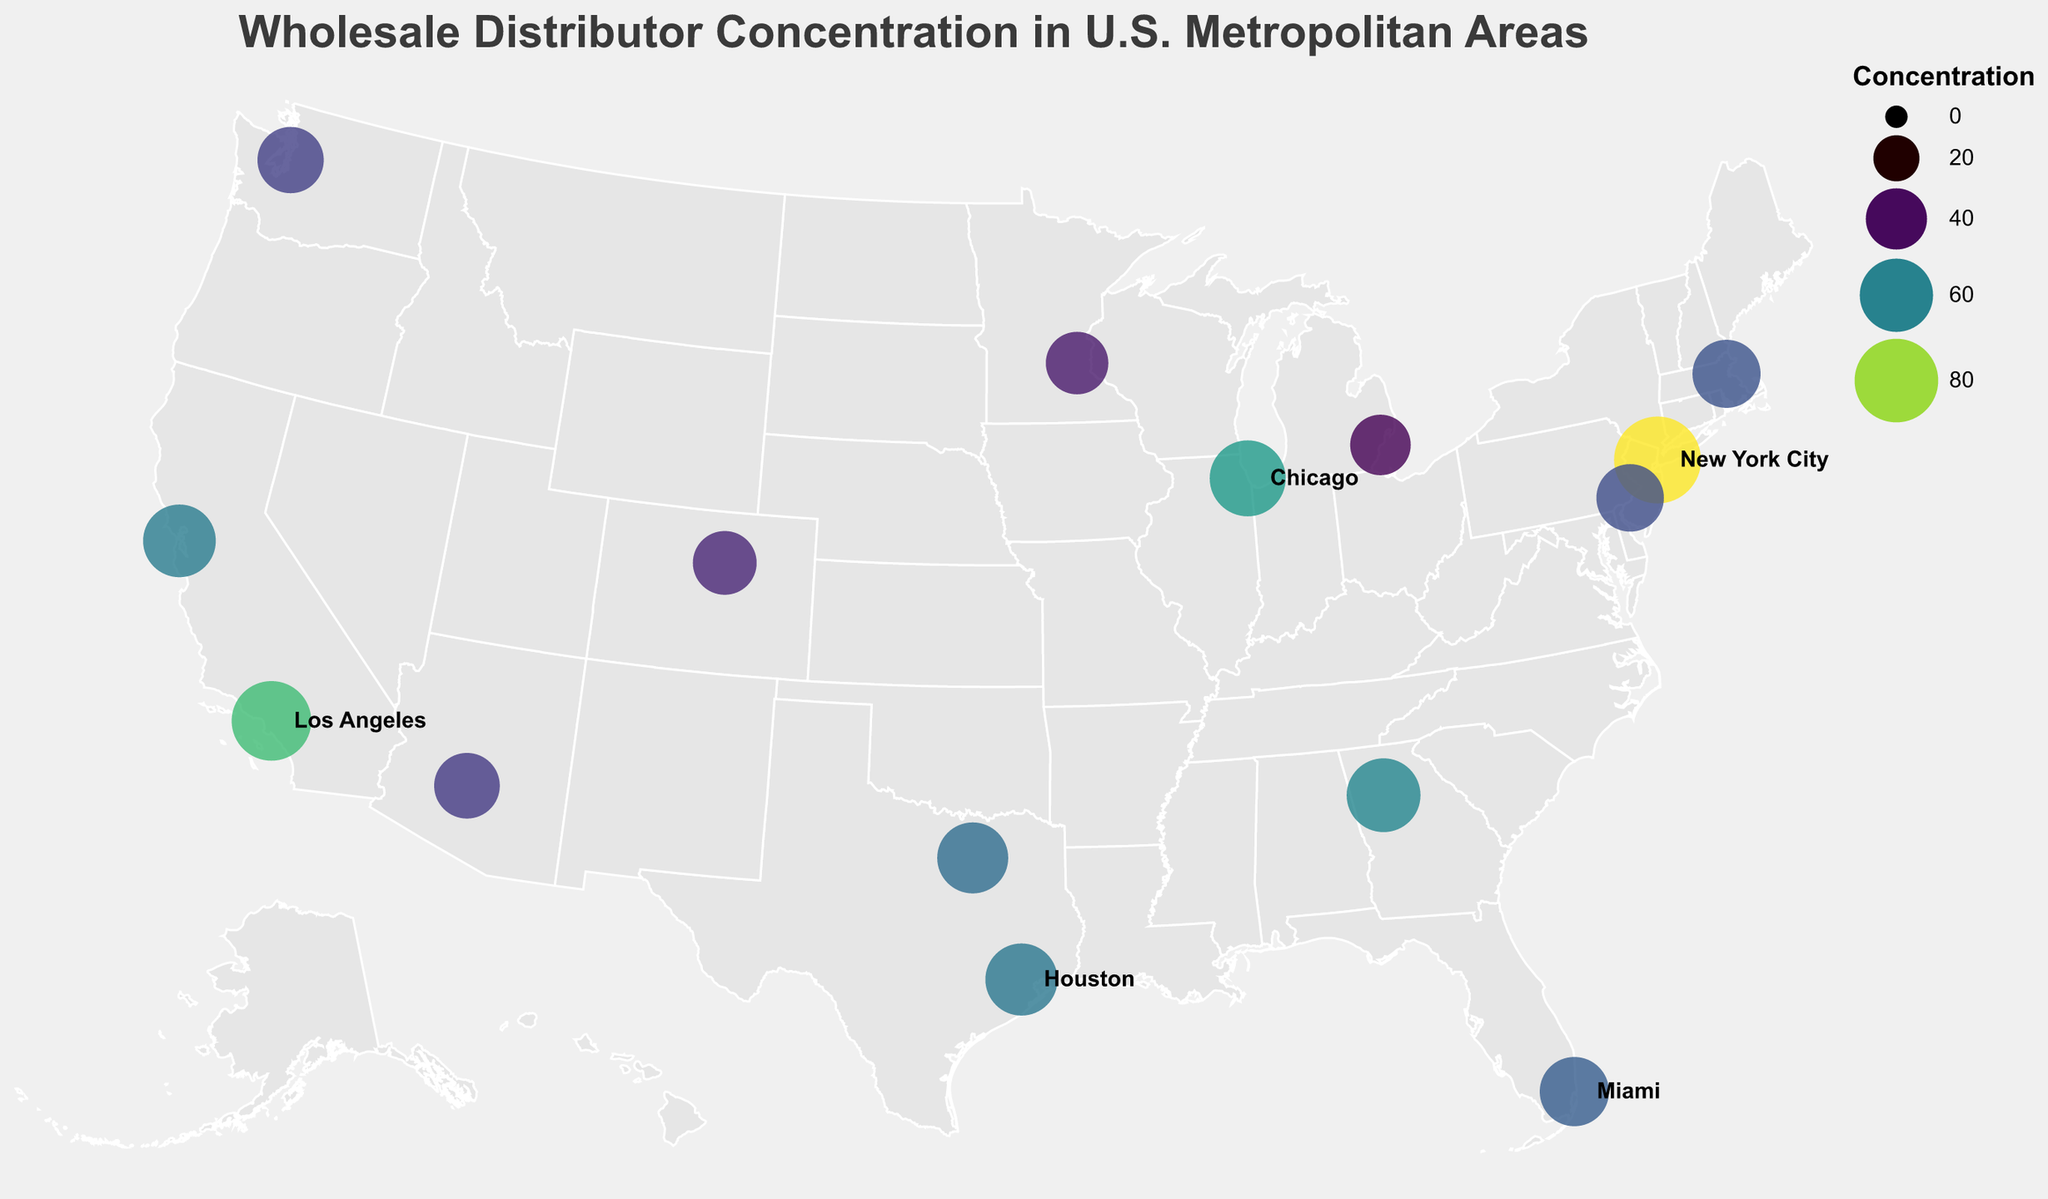Which city has the highest concentration of wholesale distributors? The city with the highest concentration of wholesale distributors is represented by the largest circle and the darkest color. This is New York City, with a concentration of 87.
Answer: New York City Which cities have a wholesale distributor concentration greater than 60? By examining the circles that are larger and darker, the cities with a concentration greater than 60 are New York City, Los Angeles, Chicago, and Atlanta.
Answer: New York City, Los Angeles, Chicago, Atlanta What is the average wholesale distributor concentration of the cities listed? Add up all the concentrations and divide by the total number of cities: (87 + 72 + 65 + 58 + 53 + 61 + 56 + 59 + 51 + 48 + 44 + 50 + 47 + 42 + 39) / 15 = 54.2
Answer: 54.2 Which city in Texas has a higher concentration of wholesale distributors, Houston or Dallas? Compare the concentrations of Houston and Dallas: Houston has 58, while Dallas has 56. Therefore, Houston has a higher concentration.
Answer: Houston What is the difference in wholesale distributor concentration between San Francisco and Philadelphia? Subtract the concentration of Philadelphia from San Francisco: 59 - 50 = 9
Answer: 9 How many cities have a wholesale distributor concentration less than 50? Count the cities with concentrations less than 50 from the dataset: Seattle (48), Phoenix (47), Minneapolis (42), Detroit (39). This makes a total of 4 cities.
Answer: 4 Which coastal city has the lowest concentration of wholesale distributors? Considering coastal cities such as New York City, Los Angeles, Miami, San Francisco, Boston, Seattle, etc., the city with the lowest concentration is Seattle with a concentration of 48.
Answer: Seattle What is the total concentration of wholesale distributors in Texas? Add the concentrations of Houston and Dallas: 58 + 56 = 114
Answer: 114 Which city has a concentration closest to the median value of the listed concentrations? First, list the concentrations in ascending order: 39, 42, 44, 47, 48, 50, 51, 53, 56, 58, 59, 61, 65, 72, 87. The median value is the middle number, 53. The city with this concentration is Miami.
Answer: Miami 